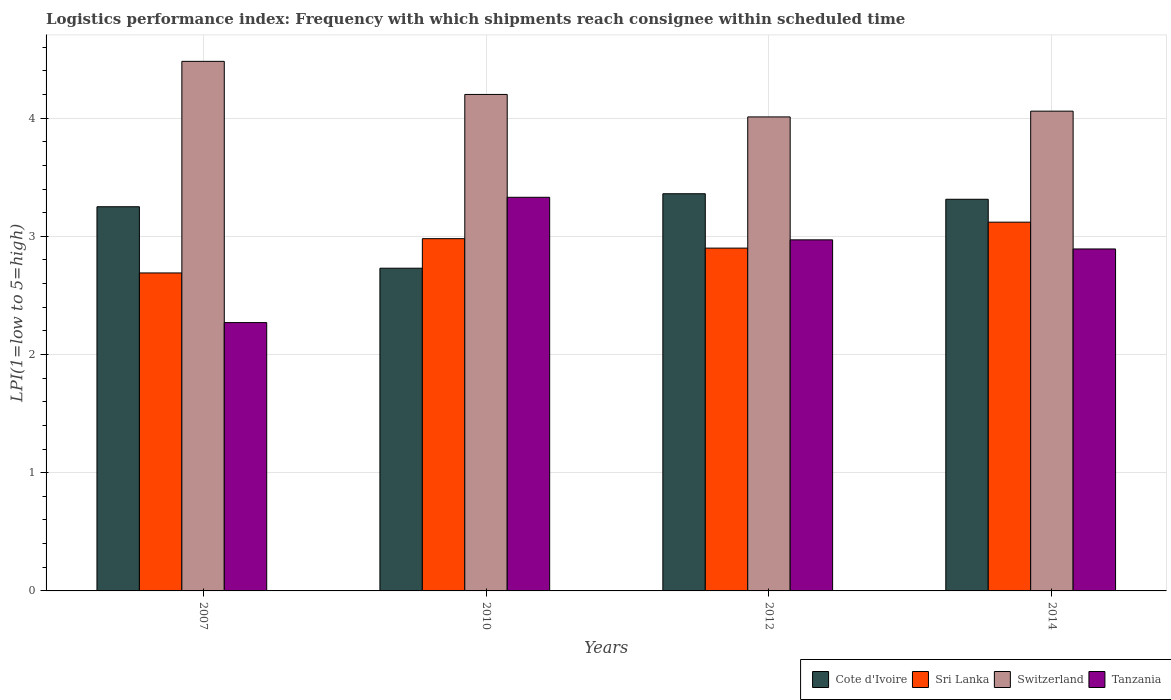Are the number of bars per tick equal to the number of legend labels?
Provide a succinct answer. Yes. What is the logistics performance index in Sri Lanka in 2007?
Offer a terse response. 2.69. Across all years, what is the maximum logistics performance index in Sri Lanka?
Make the answer very short. 3.12. Across all years, what is the minimum logistics performance index in Sri Lanka?
Your answer should be very brief. 2.69. In which year was the logistics performance index in Tanzania maximum?
Your response must be concise. 2010. In which year was the logistics performance index in Sri Lanka minimum?
Offer a terse response. 2007. What is the total logistics performance index in Sri Lanka in the graph?
Give a very brief answer. 11.69. What is the difference between the logistics performance index in Switzerland in 2010 and that in 2012?
Make the answer very short. 0.19. What is the difference between the logistics performance index in Switzerland in 2007 and the logistics performance index in Tanzania in 2014?
Give a very brief answer. 1.59. What is the average logistics performance index in Tanzania per year?
Give a very brief answer. 2.87. In the year 2012, what is the difference between the logistics performance index in Tanzania and logistics performance index in Sri Lanka?
Your response must be concise. 0.07. What is the ratio of the logistics performance index in Sri Lanka in 2007 to that in 2014?
Provide a short and direct response. 0.86. Is the logistics performance index in Sri Lanka in 2007 less than that in 2014?
Offer a terse response. Yes. Is the difference between the logistics performance index in Tanzania in 2010 and 2012 greater than the difference between the logistics performance index in Sri Lanka in 2010 and 2012?
Keep it short and to the point. Yes. What is the difference between the highest and the second highest logistics performance index in Switzerland?
Keep it short and to the point. 0.28. What is the difference between the highest and the lowest logistics performance index in Switzerland?
Provide a short and direct response. 0.47. In how many years, is the logistics performance index in Cote d'Ivoire greater than the average logistics performance index in Cote d'Ivoire taken over all years?
Give a very brief answer. 3. What does the 1st bar from the left in 2012 represents?
Your answer should be very brief. Cote d'Ivoire. What does the 1st bar from the right in 2012 represents?
Offer a very short reply. Tanzania. How many bars are there?
Offer a very short reply. 16. Are all the bars in the graph horizontal?
Give a very brief answer. No. What is the difference between two consecutive major ticks on the Y-axis?
Give a very brief answer. 1. Does the graph contain grids?
Provide a short and direct response. Yes. How many legend labels are there?
Keep it short and to the point. 4. What is the title of the graph?
Make the answer very short. Logistics performance index: Frequency with which shipments reach consignee within scheduled time. What is the label or title of the Y-axis?
Make the answer very short. LPI(1=low to 5=high). What is the LPI(1=low to 5=high) of Sri Lanka in 2007?
Your response must be concise. 2.69. What is the LPI(1=low to 5=high) in Switzerland in 2007?
Ensure brevity in your answer.  4.48. What is the LPI(1=low to 5=high) of Tanzania in 2007?
Give a very brief answer. 2.27. What is the LPI(1=low to 5=high) in Cote d'Ivoire in 2010?
Offer a terse response. 2.73. What is the LPI(1=low to 5=high) of Sri Lanka in 2010?
Offer a very short reply. 2.98. What is the LPI(1=low to 5=high) of Tanzania in 2010?
Keep it short and to the point. 3.33. What is the LPI(1=low to 5=high) of Cote d'Ivoire in 2012?
Your answer should be very brief. 3.36. What is the LPI(1=low to 5=high) of Sri Lanka in 2012?
Make the answer very short. 2.9. What is the LPI(1=low to 5=high) of Switzerland in 2012?
Ensure brevity in your answer.  4.01. What is the LPI(1=low to 5=high) in Tanzania in 2012?
Your response must be concise. 2.97. What is the LPI(1=low to 5=high) of Cote d'Ivoire in 2014?
Your response must be concise. 3.31. What is the LPI(1=low to 5=high) of Sri Lanka in 2014?
Offer a terse response. 3.12. What is the LPI(1=low to 5=high) in Switzerland in 2014?
Provide a short and direct response. 4.06. What is the LPI(1=low to 5=high) of Tanzania in 2014?
Offer a very short reply. 2.89. Across all years, what is the maximum LPI(1=low to 5=high) of Cote d'Ivoire?
Your answer should be compact. 3.36. Across all years, what is the maximum LPI(1=low to 5=high) of Sri Lanka?
Your response must be concise. 3.12. Across all years, what is the maximum LPI(1=low to 5=high) in Switzerland?
Provide a succinct answer. 4.48. Across all years, what is the maximum LPI(1=low to 5=high) in Tanzania?
Make the answer very short. 3.33. Across all years, what is the minimum LPI(1=low to 5=high) of Cote d'Ivoire?
Provide a succinct answer. 2.73. Across all years, what is the minimum LPI(1=low to 5=high) of Sri Lanka?
Make the answer very short. 2.69. Across all years, what is the minimum LPI(1=low to 5=high) of Switzerland?
Your answer should be compact. 4.01. Across all years, what is the minimum LPI(1=low to 5=high) in Tanzania?
Provide a short and direct response. 2.27. What is the total LPI(1=low to 5=high) of Cote d'Ivoire in the graph?
Make the answer very short. 12.65. What is the total LPI(1=low to 5=high) of Sri Lanka in the graph?
Offer a terse response. 11.69. What is the total LPI(1=low to 5=high) in Switzerland in the graph?
Your answer should be very brief. 16.75. What is the total LPI(1=low to 5=high) of Tanzania in the graph?
Give a very brief answer. 11.46. What is the difference between the LPI(1=low to 5=high) of Cote d'Ivoire in 2007 and that in 2010?
Provide a short and direct response. 0.52. What is the difference between the LPI(1=low to 5=high) in Sri Lanka in 2007 and that in 2010?
Ensure brevity in your answer.  -0.29. What is the difference between the LPI(1=low to 5=high) of Switzerland in 2007 and that in 2010?
Ensure brevity in your answer.  0.28. What is the difference between the LPI(1=low to 5=high) of Tanzania in 2007 and that in 2010?
Your answer should be compact. -1.06. What is the difference between the LPI(1=low to 5=high) in Cote d'Ivoire in 2007 and that in 2012?
Provide a short and direct response. -0.11. What is the difference between the LPI(1=low to 5=high) in Sri Lanka in 2007 and that in 2012?
Your answer should be compact. -0.21. What is the difference between the LPI(1=low to 5=high) of Switzerland in 2007 and that in 2012?
Offer a terse response. 0.47. What is the difference between the LPI(1=low to 5=high) of Tanzania in 2007 and that in 2012?
Your response must be concise. -0.7. What is the difference between the LPI(1=low to 5=high) of Cote d'Ivoire in 2007 and that in 2014?
Give a very brief answer. -0.06. What is the difference between the LPI(1=low to 5=high) of Sri Lanka in 2007 and that in 2014?
Your answer should be very brief. -0.43. What is the difference between the LPI(1=low to 5=high) in Switzerland in 2007 and that in 2014?
Make the answer very short. 0.42. What is the difference between the LPI(1=low to 5=high) in Tanzania in 2007 and that in 2014?
Give a very brief answer. -0.62. What is the difference between the LPI(1=low to 5=high) in Cote d'Ivoire in 2010 and that in 2012?
Make the answer very short. -0.63. What is the difference between the LPI(1=low to 5=high) of Switzerland in 2010 and that in 2012?
Offer a very short reply. 0.19. What is the difference between the LPI(1=low to 5=high) in Tanzania in 2010 and that in 2012?
Your answer should be compact. 0.36. What is the difference between the LPI(1=low to 5=high) of Cote d'Ivoire in 2010 and that in 2014?
Ensure brevity in your answer.  -0.58. What is the difference between the LPI(1=low to 5=high) in Sri Lanka in 2010 and that in 2014?
Offer a very short reply. -0.14. What is the difference between the LPI(1=low to 5=high) in Switzerland in 2010 and that in 2014?
Your answer should be compact. 0.14. What is the difference between the LPI(1=low to 5=high) in Tanzania in 2010 and that in 2014?
Provide a short and direct response. 0.44. What is the difference between the LPI(1=low to 5=high) in Cote d'Ivoire in 2012 and that in 2014?
Offer a terse response. 0.05. What is the difference between the LPI(1=low to 5=high) of Sri Lanka in 2012 and that in 2014?
Keep it short and to the point. -0.22. What is the difference between the LPI(1=low to 5=high) in Switzerland in 2012 and that in 2014?
Your answer should be very brief. -0.05. What is the difference between the LPI(1=low to 5=high) of Tanzania in 2012 and that in 2014?
Offer a terse response. 0.08. What is the difference between the LPI(1=low to 5=high) of Cote d'Ivoire in 2007 and the LPI(1=low to 5=high) of Sri Lanka in 2010?
Offer a terse response. 0.27. What is the difference between the LPI(1=low to 5=high) of Cote d'Ivoire in 2007 and the LPI(1=low to 5=high) of Switzerland in 2010?
Give a very brief answer. -0.95. What is the difference between the LPI(1=low to 5=high) in Cote d'Ivoire in 2007 and the LPI(1=low to 5=high) in Tanzania in 2010?
Your answer should be very brief. -0.08. What is the difference between the LPI(1=low to 5=high) in Sri Lanka in 2007 and the LPI(1=low to 5=high) in Switzerland in 2010?
Your answer should be very brief. -1.51. What is the difference between the LPI(1=low to 5=high) in Sri Lanka in 2007 and the LPI(1=low to 5=high) in Tanzania in 2010?
Your answer should be compact. -0.64. What is the difference between the LPI(1=low to 5=high) in Switzerland in 2007 and the LPI(1=low to 5=high) in Tanzania in 2010?
Provide a short and direct response. 1.15. What is the difference between the LPI(1=low to 5=high) of Cote d'Ivoire in 2007 and the LPI(1=low to 5=high) of Switzerland in 2012?
Make the answer very short. -0.76. What is the difference between the LPI(1=low to 5=high) in Cote d'Ivoire in 2007 and the LPI(1=low to 5=high) in Tanzania in 2012?
Give a very brief answer. 0.28. What is the difference between the LPI(1=low to 5=high) in Sri Lanka in 2007 and the LPI(1=low to 5=high) in Switzerland in 2012?
Your response must be concise. -1.32. What is the difference between the LPI(1=low to 5=high) in Sri Lanka in 2007 and the LPI(1=low to 5=high) in Tanzania in 2012?
Keep it short and to the point. -0.28. What is the difference between the LPI(1=low to 5=high) of Switzerland in 2007 and the LPI(1=low to 5=high) of Tanzania in 2012?
Provide a succinct answer. 1.51. What is the difference between the LPI(1=low to 5=high) of Cote d'Ivoire in 2007 and the LPI(1=low to 5=high) of Sri Lanka in 2014?
Make the answer very short. 0.13. What is the difference between the LPI(1=low to 5=high) of Cote d'Ivoire in 2007 and the LPI(1=low to 5=high) of Switzerland in 2014?
Ensure brevity in your answer.  -0.81. What is the difference between the LPI(1=low to 5=high) in Cote d'Ivoire in 2007 and the LPI(1=low to 5=high) in Tanzania in 2014?
Provide a short and direct response. 0.36. What is the difference between the LPI(1=low to 5=high) in Sri Lanka in 2007 and the LPI(1=low to 5=high) in Switzerland in 2014?
Give a very brief answer. -1.37. What is the difference between the LPI(1=low to 5=high) of Sri Lanka in 2007 and the LPI(1=low to 5=high) of Tanzania in 2014?
Provide a succinct answer. -0.2. What is the difference between the LPI(1=low to 5=high) of Switzerland in 2007 and the LPI(1=low to 5=high) of Tanzania in 2014?
Your answer should be very brief. 1.59. What is the difference between the LPI(1=low to 5=high) in Cote d'Ivoire in 2010 and the LPI(1=low to 5=high) in Sri Lanka in 2012?
Your response must be concise. -0.17. What is the difference between the LPI(1=low to 5=high) of Cote d'Ivoire in 2010 and the LPI(1=low to 5=high) of Switzerland in 2012?
Your answer should be very brief. -1.28. What is the difference between the LPI(1=low to 5=high) of Cote d'Ivoire in 2010 and the LPI(1=low to 5=high) of Tanzania in 2012?
Provide a short and direct response. -0.24. What is the difference between the LPI(1=low to 5=high) in Sri Lanka in 2010 and the LPI(1=low to 5=high) in Switzerland in 2012?
Provide a short and direct response. -1.03. What is the difference between the LPI(1=low to 5=high) in Switzerland in 2010 and the LPI(1=low to 5=high) in Tanzania in 2012?
Provide a succinct answer. 1.23. What is the difference between the LPI(1=low to 5=high) in Cote d'Ivoire in 2010 and the LPI(1=low to 5=high) in Sri Lanka in 2014?
Provide a succinct answer. -0.39. What is the difference between the LPI(1=low to 5=high) in Cote d'Ivoire in 2010 and the LPI(1=low to 5=high) in Switzerland in 2014?
Provide a succinct answer. -1.33. What is the difference between the LPI(1=low to 5=high) in Cote d'Ivoire in 2010 and the LPI(1=low to 5=high) in Tanzania in 2014?
Keep it short and to the point. -0.16. What is the difference between the LPI(1=low to 5=high) in Sri Lanka in 2010 and the LPI(1=low to 5=high) in Switzerland in 2014?
Provide a succinct answer. -1.08. What is the difference between the LPI(1=low to 5=high) of Sri Lanka in 2010 and the LPI(1=low to 5=high) of Tanzania in 2014?
Provide a succinct answer. 0.09. What is the difference between the LPI(1=low to 5=high) in Switzerland in 2010 and the LPI(1=low to 5=high) in Tanzania in 2014?
Offer a very short reply. 1.31. What is the difference between the LPI(1=low to 5=high) of Cote d'Ivoire in 2012 and the LPI(1=low to 5=high) of Sri Lanka in 2014?
Provide a succinct answer. 0.24. What is the difference between the LPI(1=low to 5=high) of Cote d'Ivoire in 2012 and the LPI(1=low to 5=high) of Switzerland in 2014?
Make the answer very short. -0.7. What is the difference between the LPI(1=low to 5=high) of Cote d'Ivoire in 2012 and the LPI(1=low to 5=high) of Tanzania in 2014?
Offer a very short reply. 0.47. What is the difference between the LPI(1=low to 5=high) in Sri Lanka in 2012 and the LPI(1=low to 5=high) in Switzerland in 2014?
Ensure brevity in your answer.  -1.16. What is the difference between the LPI(1=low to 5=high) in Sri Lanka in 2012 and the LPI(1=low to 5=high) in Tanzania in 2014?
Offer a very short reply. 0.01. What is the difference between the LPI(1=low to 5=high) of Switzerland in 2012 and the LPI(1=low to 5=high) of Tanzania in 2014?
Your answer should be compact. 1.12. What is the average LPI(1=low to 5=high) in Cote d'Ivoire per year?
Give a very brief answer. 3.16. What is the average LPI(1=low to 5=high) in Sri Lanka per year?
Keep it short and to the point. 2.92. What is the average LPI(1=low to 5=high) in Switzerland per year?
Provide a succinct answer. 4.19. What is the average LPI(1=low to 5=high) in Tanzania per year?
Your answer should be compact. 2.87. In the year 2007, what is the difference between the LPI(1=low to 5=high) of Cote d'Ivoire and LPI(1=low to 5=high) of Sri Lanka?
Offer a very short reply. 0.56. In the year 2007, what is the difference between the LPI(1=low to 5=high) in Cote d'Ivoire and LPI(1=low to 5=high) in Switzerland?
Offer a very short reply. -1.23. In the year 2007, what is the difference between the LPI(1=low to 5=high) of Sri Lanka and LPI(1=low to 5=high) of Switzerland?
Your answer should be very brief. -1.79. In the year 2007, what is the difference between the LPI(1=low to 5=high) in Sri Lanka and LPI(1=low to 5=high) in Tanzania?
Your answer should be compact. 0.42. In the year 2007, what is the difference between the LPI(1=low to 5=high) of Switzerland and LPI(1=low to 5=high) of Tanzania?
Ensure brevity in your answer.  2.21. In the year 2010, what is the difference between the LPI(1=low to 5=high) of Cote d'Ivoire and LPI(1=low to 5=high) of Sri Lanka?
Your answer should be very brief. -0.25. In the year 2010, what is the difference between the LPI(1=low to 5=high) in Cote d'Ivoire and LPI(1=low to 5=high) in Switzerland?
Offer a terse response. -1.47. In the year 2010, what is the difference between the LPI(1=low to 5=high) of Cote d'Ivoire and LPI(1=low to 5=high) of Tanzania?
Your response must be concise. -0.6. In the year 2010, what is the difference between the LPI(1=low to 5=high) of Sri Lanka and LPI(1=low to 5=high) of Switzerland?
Your answer should be very brief. -1.22. In the year 2010, what is the difference between the LPI(1=low to 5=high) of Sri Lanka and LPI(1=low to 5=high) of Tanzania?
Make the answer very short. -0.35. In the year 2010, what is the difference between the LPI(1=low to 5=high) of Switzerland and LPI(1=low to 5=high) of Tanzania?
Offer a very short reply. 0.87. In the year 2012, what is the difference between the LPI(1=low to 5=high) in Cote d'Ivoire and LPI(1=low to 5=high) in Sri Lanka?
Provide a short and direct response. 0.46. In the year 2012, what is the difference between the LPI(1=low to 5=high) in Cote d'Ivoire and LPI(1=low to 5=high) in Switzerland?
Keep it short and to the point. -0.65. In the year 2012, what is the difference between the LPI(1=low to 5=high) of Cote d'Ivoire and LPI(1=low to 5=high) of Tanzania?
Offer a terse response. 0.39. In the year 2012, what is the difference between the LPI(1=low to 5=high) in Sri Lanka and LPI(1=low to 5=high) in Switzerland?
Offer a terse response. -1.11. In the year 2012, what is the difference between the LPI(1=low to 5=high) of Sri Lanka and LPI(1=low to 5=high) of Tanzania?
Provide a short and direct response. -0.07. In the year 2014, what is the difference between the LPI(1=low to 5=high) in Cote d'Ivoire and LPI(1=low to 5=high) in Sri Lanka?
Offer a very short reply. 0.19. In the year 2014, what is the difference between the LPI(1=low to 5=high) in Cote d'Ivoire and LPI(1=low to 5=high) in Switzerland?
Give a very brief answer. -0.75. In the year 2014, what is the difference between the LPI(1=low to 5=high) in Cote d'Ivoire and LPI(1=low to 5=high) in Tanzania?
Your response must be concise. 0.42. In the year 2014, what is the difference between the LPI(1=low to 5=high) in Sri Lanka and LPI(1=low to 5=high) in Switzerland?
Ensure brevity in your answer.  -0.94. In the year 2014, what is the difference between the LPI(1=low to 5=high) of Sri Lanka and LPI(1=low to 5=high) of Tanzania?
Your response must be concise. 0.23. In the year 2014, what is the difference between the LPI(1=low to 5=high) in Switzerland and LPI(1=low to 5=high) in Tanzania?
Your answer should be compact. 1.17. What is the ratio of the LPI(1=low to 5=high) of Cote d'Ivoire in 2007 to that in 2010?
Provide a short and direct response. 1.19. What is the ratio of the LPI(1=low to 5=high) of Sri Lanka in 2007 to that in 2010?
Offer a terse response. 0.9. What is the ratio of the LPI(1=low to 5=high) of Switzerland in 2007 to that in 2010?
Your answer should be compact. 1.07. What is the ratio of the LPI(1=low to 5=high) of Tanzania in 2007 to that in 2010?
Your response must be concise. 0.68. What is the ratio of the LPI(1=low to 5=high) in Cote d'Ivoire in 2007 to that in 2012?
Your response must be concise. 0.97. What is the ratio of the LPI(1=low to 5=high) in Sri Lanka in 2007 to that in 2012?
Give a very brief answer. 0.93. What is the ratio of the LPI(1=low to 5=high) in Switzerland in 2007 to that in 2012?
Your answer should be compact. 1.12. What is the ratio of the LPI(1=low to 5=high) in Tanzania in 2007 to that in 2012?
Your answer should be very brief. 0.76. What is the ratio of the LPI(1=low to 5=high) of Cote d'Ivoire in 2007 to that in 2014?
Your answer should be very brief. 0.98. What is the ratio of the LPI(1=low to 5=high) of Sri Lanka in 2007 to that in 2014?
Your answer should be very brief. 0.86. What is the ratio of the LPI(1=low to 5=high) in Switzerland in 2007 to that in 2014?
Your answer should be compact. 1.1. What is the ratio of the LPI(1=low to 5=high) in Tanzania in 2007 to that in 2014?
Make the answer very short. 0.78. What is the ratio of the LPI(1=low to 5=high) of Cote d'Ivoire in 2010 to that in 2012?
Offer a very short reply. 0.81. What is the ratio of the LPI(1=low to 5=high) of Sri Lanka in 2010 to that in 2012?
Offer a very short reply. 1.03. What is the ratio of the LPI(1=low to 5=high) of Switzerland in 2010 to that in 2012?
Your answer should be very brief. 1.05. What is the ratio of the LPI(1=low to 5=high) of Tanzania in 2010 to that in 2012?
Your answer should be very brief. 1.12. What is the ratio of the LPI(1=low to 5=high) in Cote d'Ivoire in 2010 to that in 2014?
Make the answer very short. 0.82. What is the ratio of the LPI(1=low to 5=high) of Sri Lanka in 2010 to that in 2014?
Provide a succinct answer. 0.96. What is the ratio of the LPI(1=low to 5=high) in Switzerland in 2010 to that in 2014?
Offer a very short reply. 1.03. What is the ratio of the LPI(1=low to 5=high) in Tanzania in 2010 to that in 2014?
Keep it short and to the point. 1.15. What is the ratio of the LPI(1=low to 5=high) of Cote d'Ivoire in 2012 to that in 2014?
Your answer should be compact. 1.01. What is the ratio of the LPI(1=low to 5=high) in Sri Lanka in 2012 to that in 2014?
Ensure brevity in your answer.  0.93. What is the ratio of the LPI(1=low to 5=high) of Tanzania in 2012 to that in 2014?
Your response must be concise. 1.03. What is the difference between the highest and the second highest LPI(1=low to 5=high) of Cote d'Ivoire?
Provide a succinct answer. 0.05. What is the difference between the highest and the second highest LPI(1=low to 5=high) of Sri Lanka?
Your answer should be compact. 0.14. What is the difference between the highest and the second highest LPI(1=low to 5=high) in Switzerland?
Give a very brief answer. 0.28. What is the difference between the highest and the second highest LPI(1=low to 5=high) in Tanzania?
Provide a short and direct response. 0.36. What is the difference between the highest and the lowest LPI(1=low to 5=high) in Cote d'Ivoire?
Offer a very short reply. 0.63. What is the difference between the highest and the lowest LPI(1=low to 5=high) in Sri Lanka?
Provide a succinct answer. 0.43. What is the difference between the highest and the lowest LPI(1=low to 5=high) of Switzerland?
Offer a very short reply. 0.47. What is the difference between the highest and the lowest LPI(1=low to 5=high) in Tanzania?
Give a very brief answer. 1.06. 